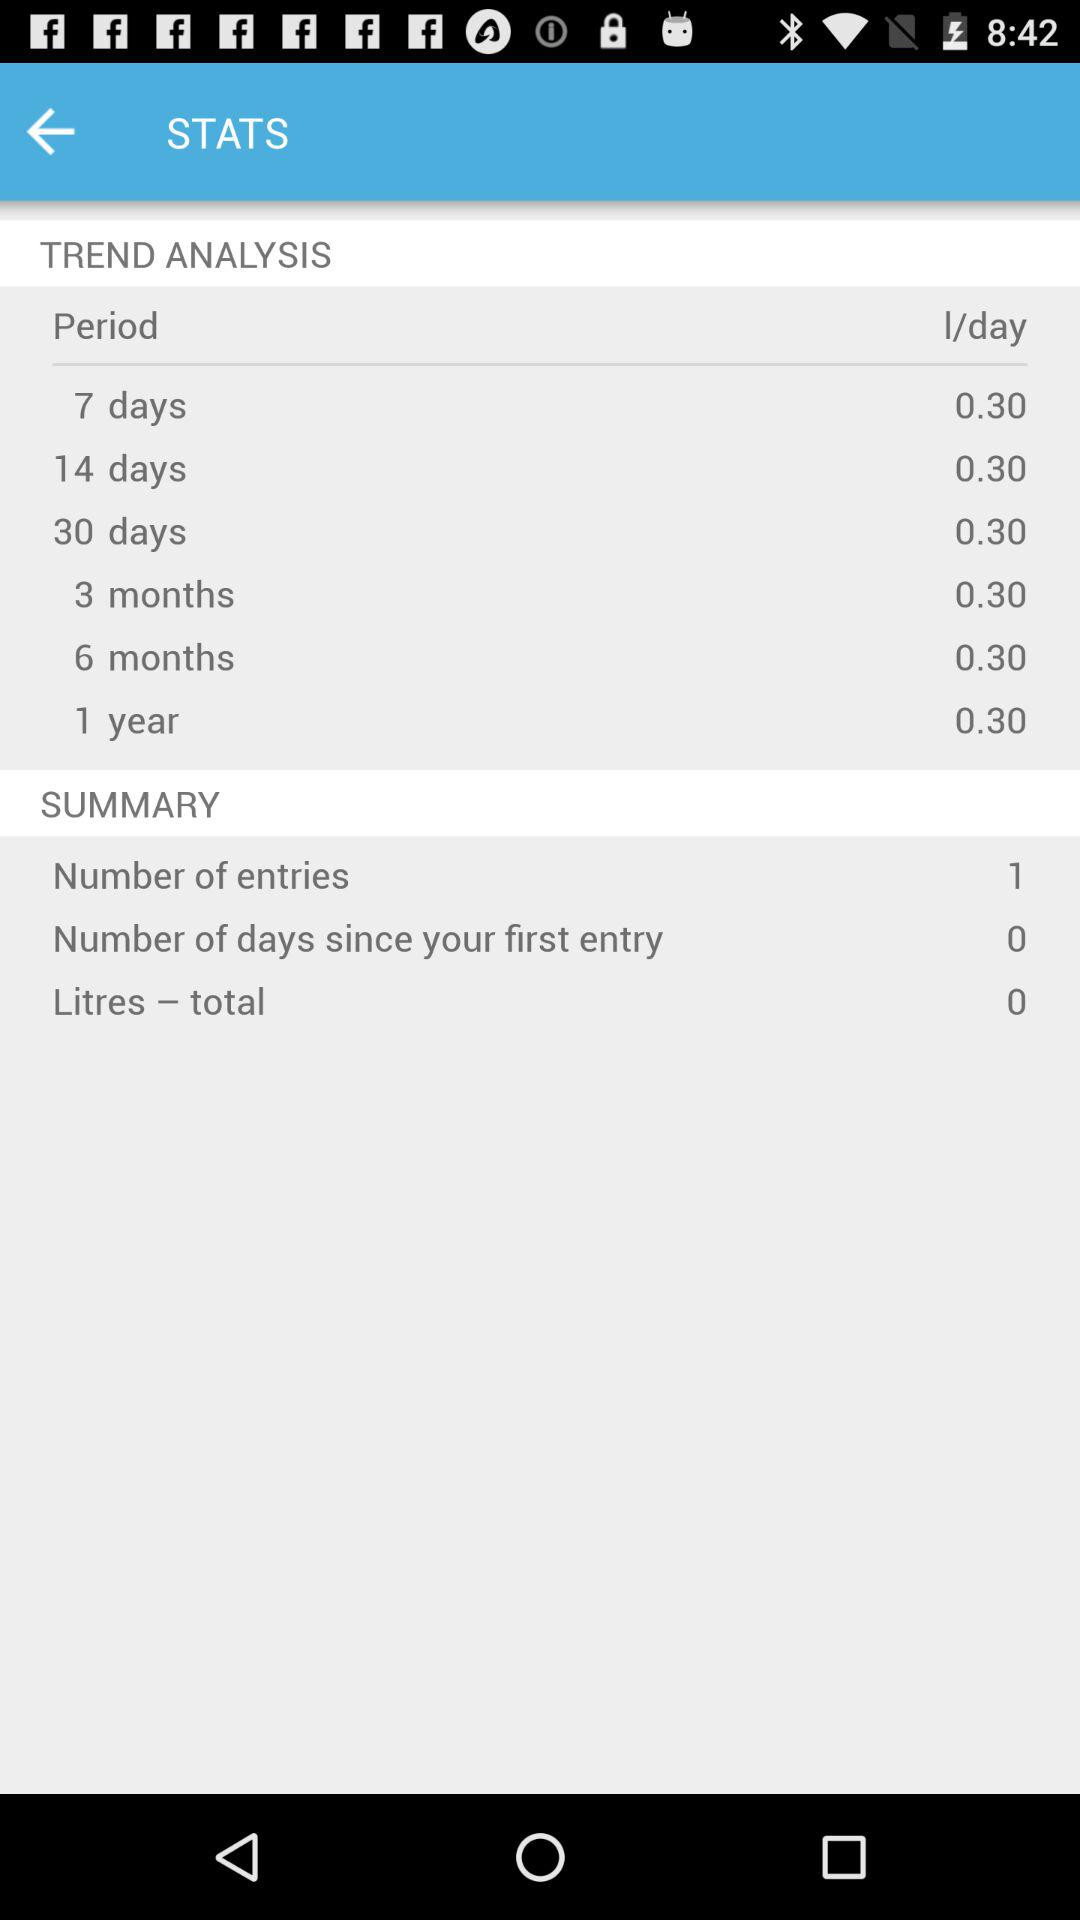How many litres in total are there? There are zero litres. 